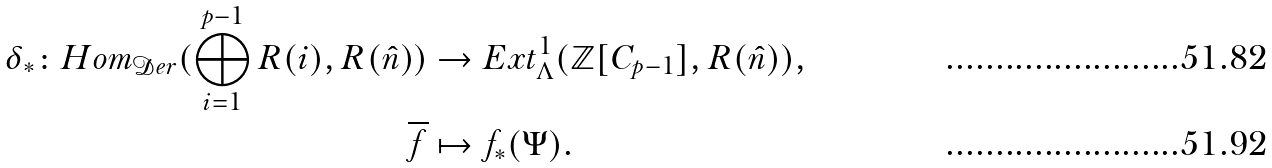Convert formula to latex. <formula><loc_0><loc_0><loc_500><loc_500>\delta _ { * } \colon H o m _ { \mathcal { D } e r } ( \bigoplus _ { i = 1 } ^ { p - 1 } R ( i ) , R ( \hat { n } ) ) & \rightarrow E x t ^ { 1 } _ { \Lambda } ( \mathbb { Z } [ C _ { p - 1 } ] , R ( \hat { n } ) ) , \\ \overline { f } & \mapsto f _ { * } ( \Psi ) .</formula> 